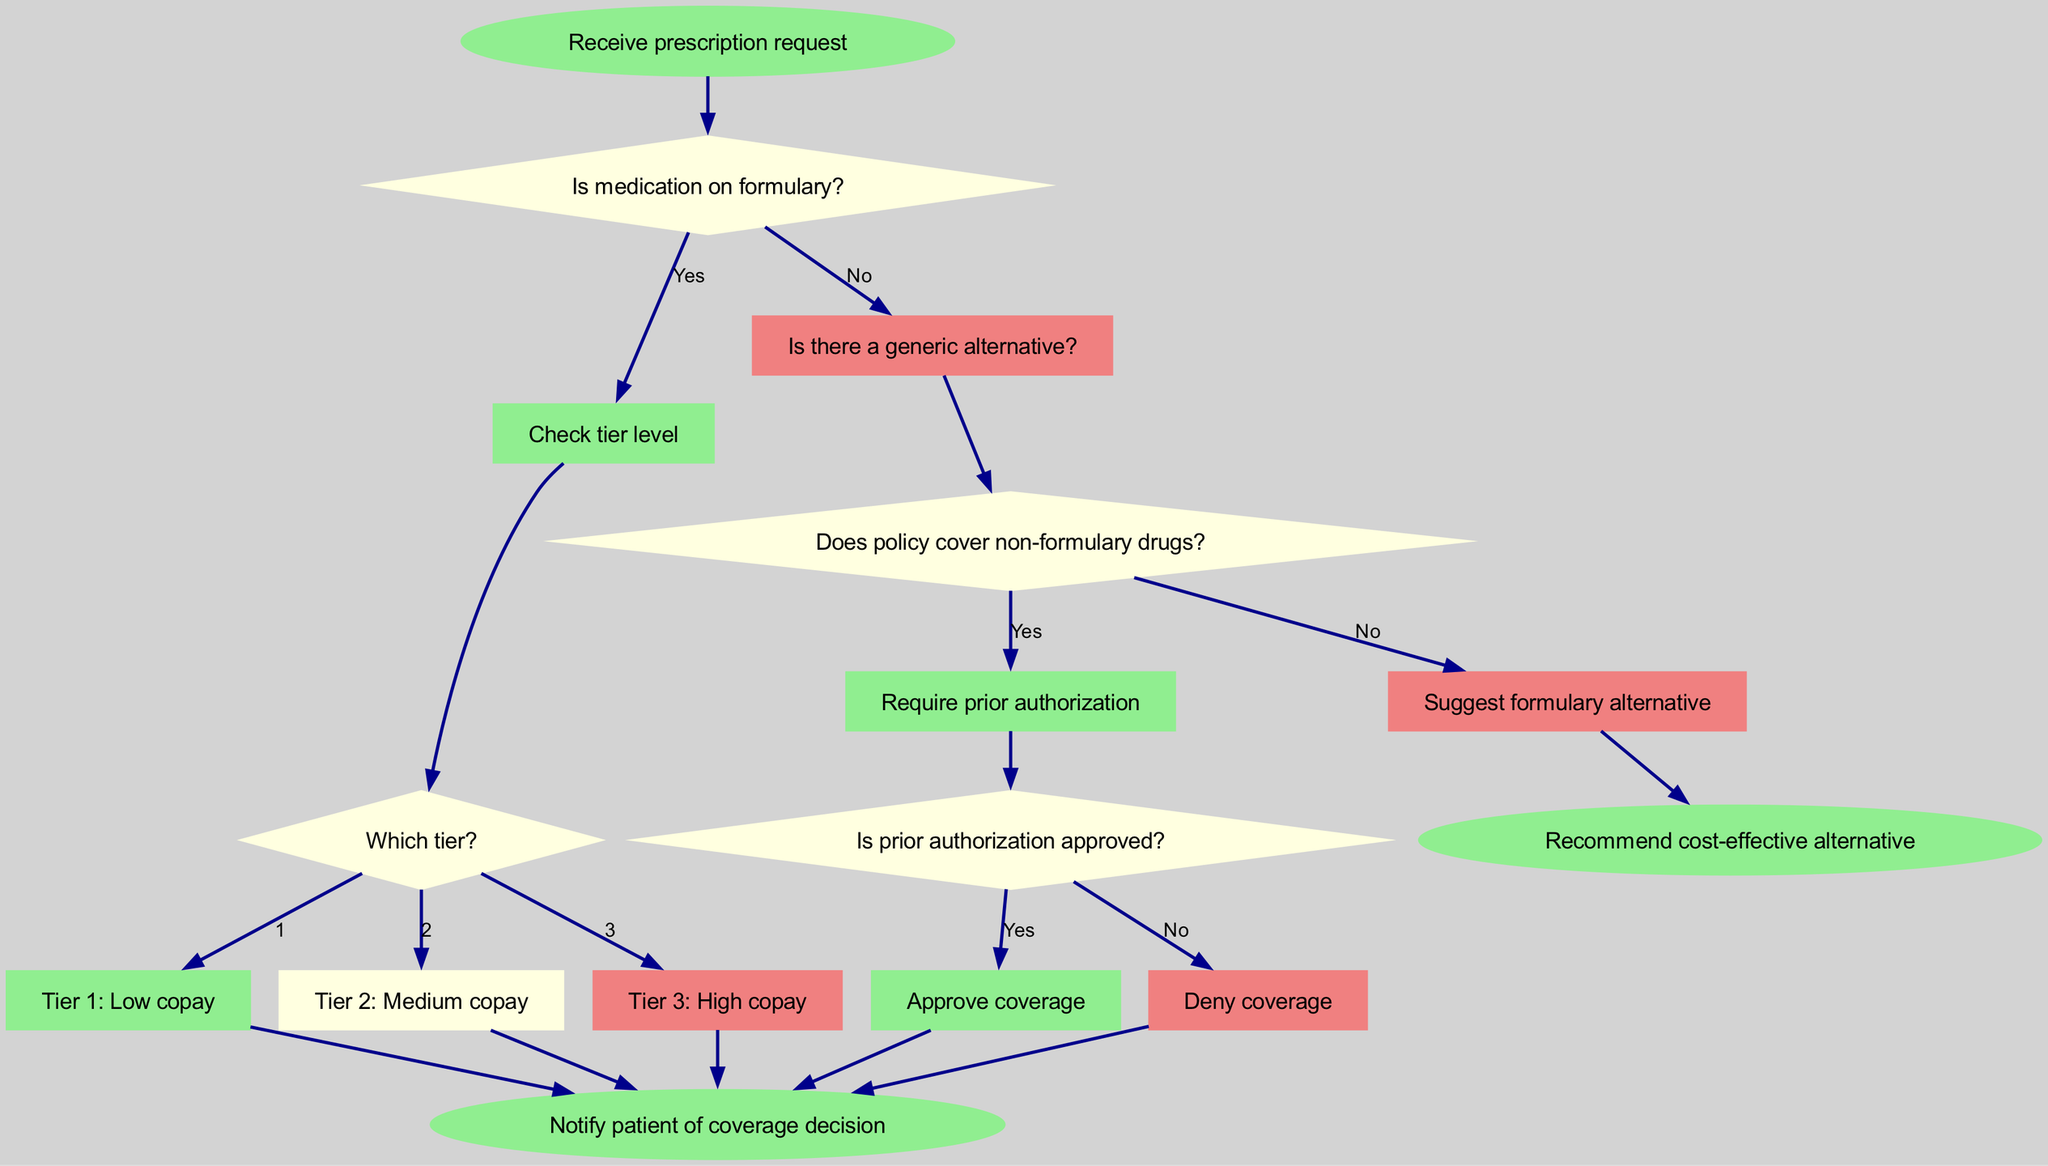What is the first step in the decision tree? The first step in the decision tree is represented by the "start" node, which states "Receive prescription request." This is the initial action taken before any decisions are made.
Answer: Receive prescription request How many decision nodes are in the diagram? In the diagram, there are four decision nodes labeled decision1, decision2, decision3, and decision4. Each of these nodes represents a point where a decision is made regarding medication coverage.
Answer: Four What happens if the medication is not on formulary and there is no generic alternative? If the medication is not on formulary and there is no generic alternative, the flow proceeds to decision3, where it checks if the policy covers non-formulary drugs.
Answer: Check policy coverage for non-formulary drugs What is the outcome if prior authorization is approved? If prior authorization is approved, the flow moves to "Approve coverage," indicating that the medication is covered under the policy. This indicates a positive outcome directly following a successful decision.
Answer: Approve coverage What label represents a medication with a low copay? The label that represents a medication with a low copay is "Tier 1: Low copay." This appears under decision2 as one of the outcomes based on the tier level of the medication.
Answer: Tier 1: Low copay What should be done if the policy does not cover non-formulary drugs? If the policy does not cover non-formulary drugs, the diagram suggests to "Suggest formulary alternative," indicating a course of action for addressing the coverage limitation.
Answer: Suggest formulary alternative What are the possible tier levels indicated in the decision tree? The possible tier levels indicated in the decision tree are Tier 1, Tier 2, and Tier 3. Each tier represents a different level of copay that a patient would incur for the medication.
Answer: Tier 1, Tier 2, Tier 3 What is the final action taken after making a coverage decision? The final action taken after making a coverage decision is to "Notify patient of coverage decision," which represents the conclusion of the decision-making process in the diagram.
Answer: Notify patient of coverage decision 